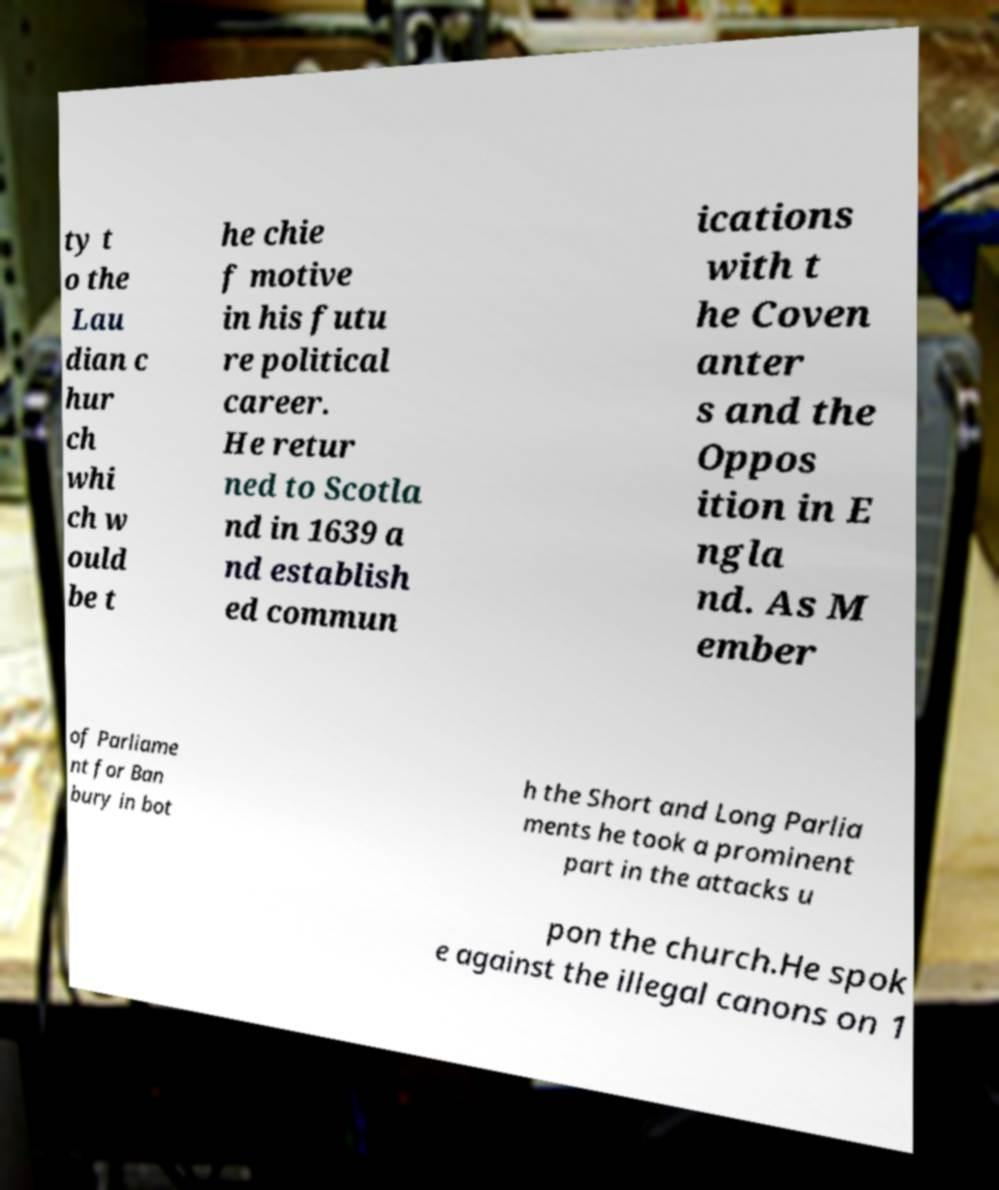Can you read and provide the text displayed in the image?This photo seems to have some interesting text. Can you extract and type it out for me? ty t o the Lau dian c hur ch whi ch w ould be t he chie f motive in his futu re political career. He retur ned to Scotla nd in 1639 a nd establish ed commun ications with t he Coven anter s and the Oppos ition in E ngla nd. As M ember of Parliame nt for Ban bury in bot h the Short and Long Parlia ments he took a prominent part in the attacks u pon the church.He spok e against the illegal canons on 1 